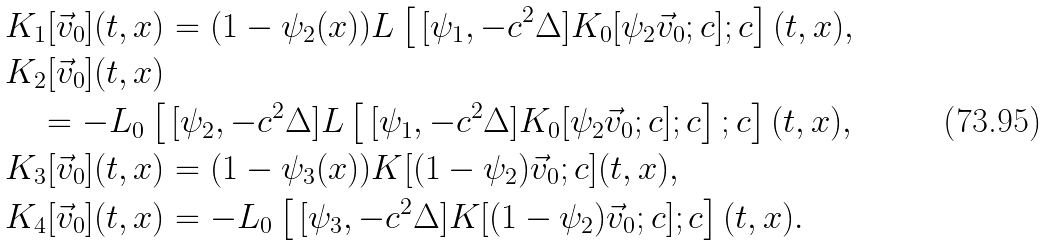<formula> <loc_0><loc_0><loc_500><loc_500>& K _ { 1 } [ \vec { v } _ { 0 } ] ( t , x ) = ( 1 - \psi _ { 2 } ( x ) ) L \left [ \, [ \psi _ { 1 } , - c ^ { 2 } \Delta ] K _ { 0 } [ \psi _ { 2 } \vec { v } _ { 0 } ; c ] ; c \right ] ( t , x ) , \\ & K _ { 2 } [ \vec { v } _ { 0 } ] ( t , x ) \\ & \quad = - L _ { 0 } \left [ \, [ \psi _ { 2 } , - c ^ { 2 } \Delta ] L \left [ \, [ \psi _ { 1 } , - c ^ { 2 } \Delta ] K _ { 0 } [ \psi _ { 2 } \vec { v } _ { 0 } ; c ] ; c \right ] ; c \right ] ( t , x ) , \\ & K _ { 3 } [ \vec { v } _ { 0 } ] ( t , x ) = ( 1 - \psi _ { 3 } ( x ) ) K [ ( 1 - \psi _ { 2 } ) \vec { v } _ { 0 } ; c ] ( t , x ) , \\ & K _ { 4 } [ \vec { v } _ { 0 } ] ( t , x ) = - L _ { 0 } \left [ \, [ \psi _ { 3 } , - c ^ { 2 } \Delta ] K [ ( 1 - \psi _ { 2 } ) \vec { v } _ { 0 } ; c ] ; c \right ] ( t , x ) .</formula> 